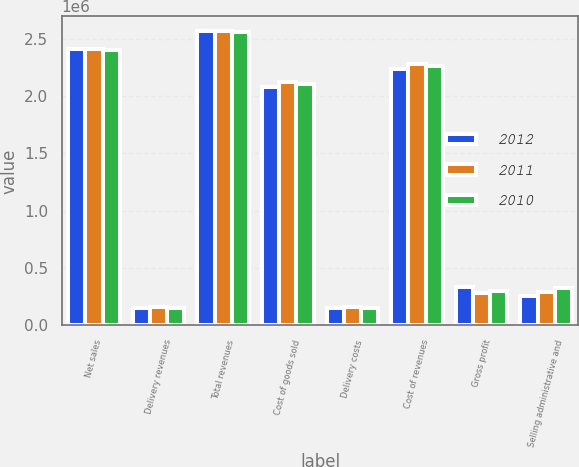Convert chart to OTSL. <chart><loc_0><loc_0><loc_500><loc_500><stacked_bar_chart><ecel><fcel>Net sales<fcel>Delivery revenues<fcel>Total revenues<fcel>Cost of goods sold<fcel>Delivery costs<fcel>Cost of revenues<fcel>Gross profit<fcel>Selling administrative and<nl><fcel>2012<fcel>2.41124e+06<fcel>156067<fcel>2.56731e+06<fcel>2.07722e+06<fcel>156067<fcel>2.23328e+06<fcel>334026<fcel>259140<nl><fcel>2011<fcel>2.40691e+06<fcel>157641<fcel>2.56455e+06<fcel>2.12304e+06<fcel>157641<fcel>2.28068e+06<fcel>283869<fcel>289993<nl><fcel>2010<fcel>2.40592e+06<fcel>152946<fcel>2.55886e+06<fcel>2.10519e+06<fcel>152946<fcel>2.25814e+06<fcel>300726<fcel>327537<nl></chart> 